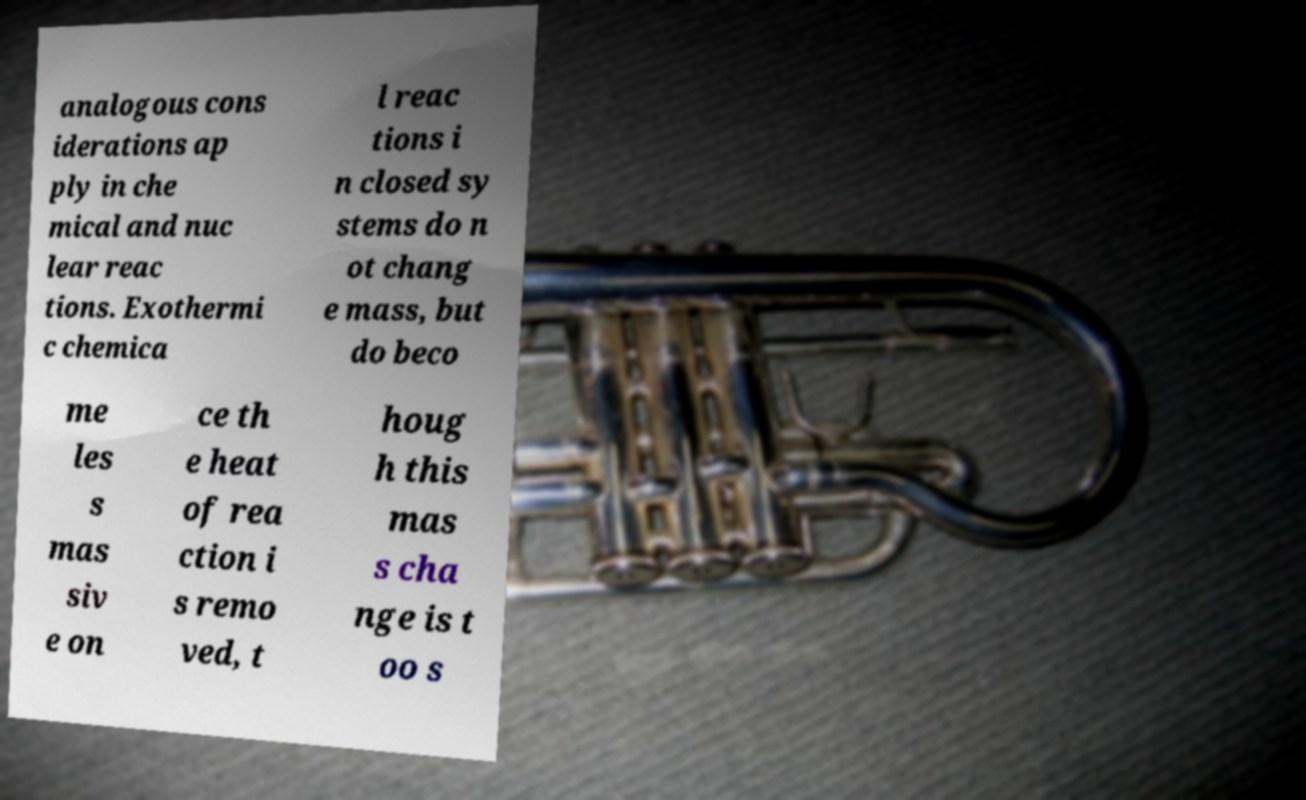There's text embedded in this image that I need extracted. Can you transcribe it verbatim? analogous cons iderations ap ply in che mical and nuc lear reac tions. Exothermi c chemica l reac tions i n closed sy stems do n ot chang e mass, but do beco me les s mas siv e on ce th e heat of rea ction i s remo ved, t houg h this mas s cha nge is t oo s 